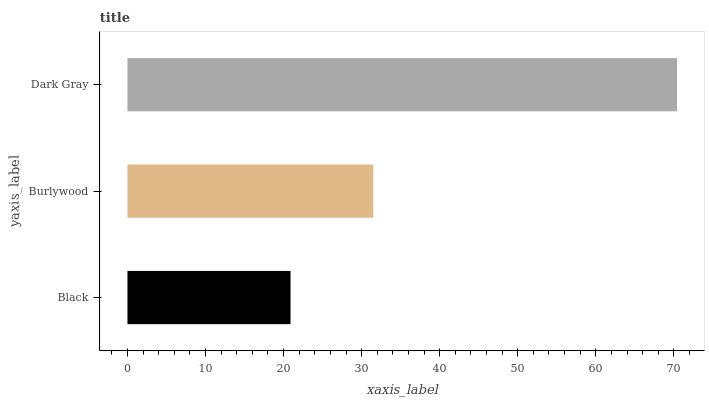Is Black the minimum?
Answer yes or no. Yes. Is Dark Gray the maximum?
Answer yes or no. Yes. Is Burlywood the minimum?
Answer yes or no. No. Is Burlywood the maximum?
Answer yes or no. No. Is Burlywood greater than Black?
Answer yes or no. Yes. Is Black less than Burlywood?
Answer yes or no. Yes. Is Black greater than Burlywood?
Answer yes or no. No. Is Burlywood less than Black?
Answer yes or no. No. Is Burlywood the high median?
Answer yes or no. Yes. Is Burlywood the low median?
Answer yes or no. Yes. Is Dark Gray the high median?
Answer yes or no. No. Is Black the low median?
Answer yes or no. No. 